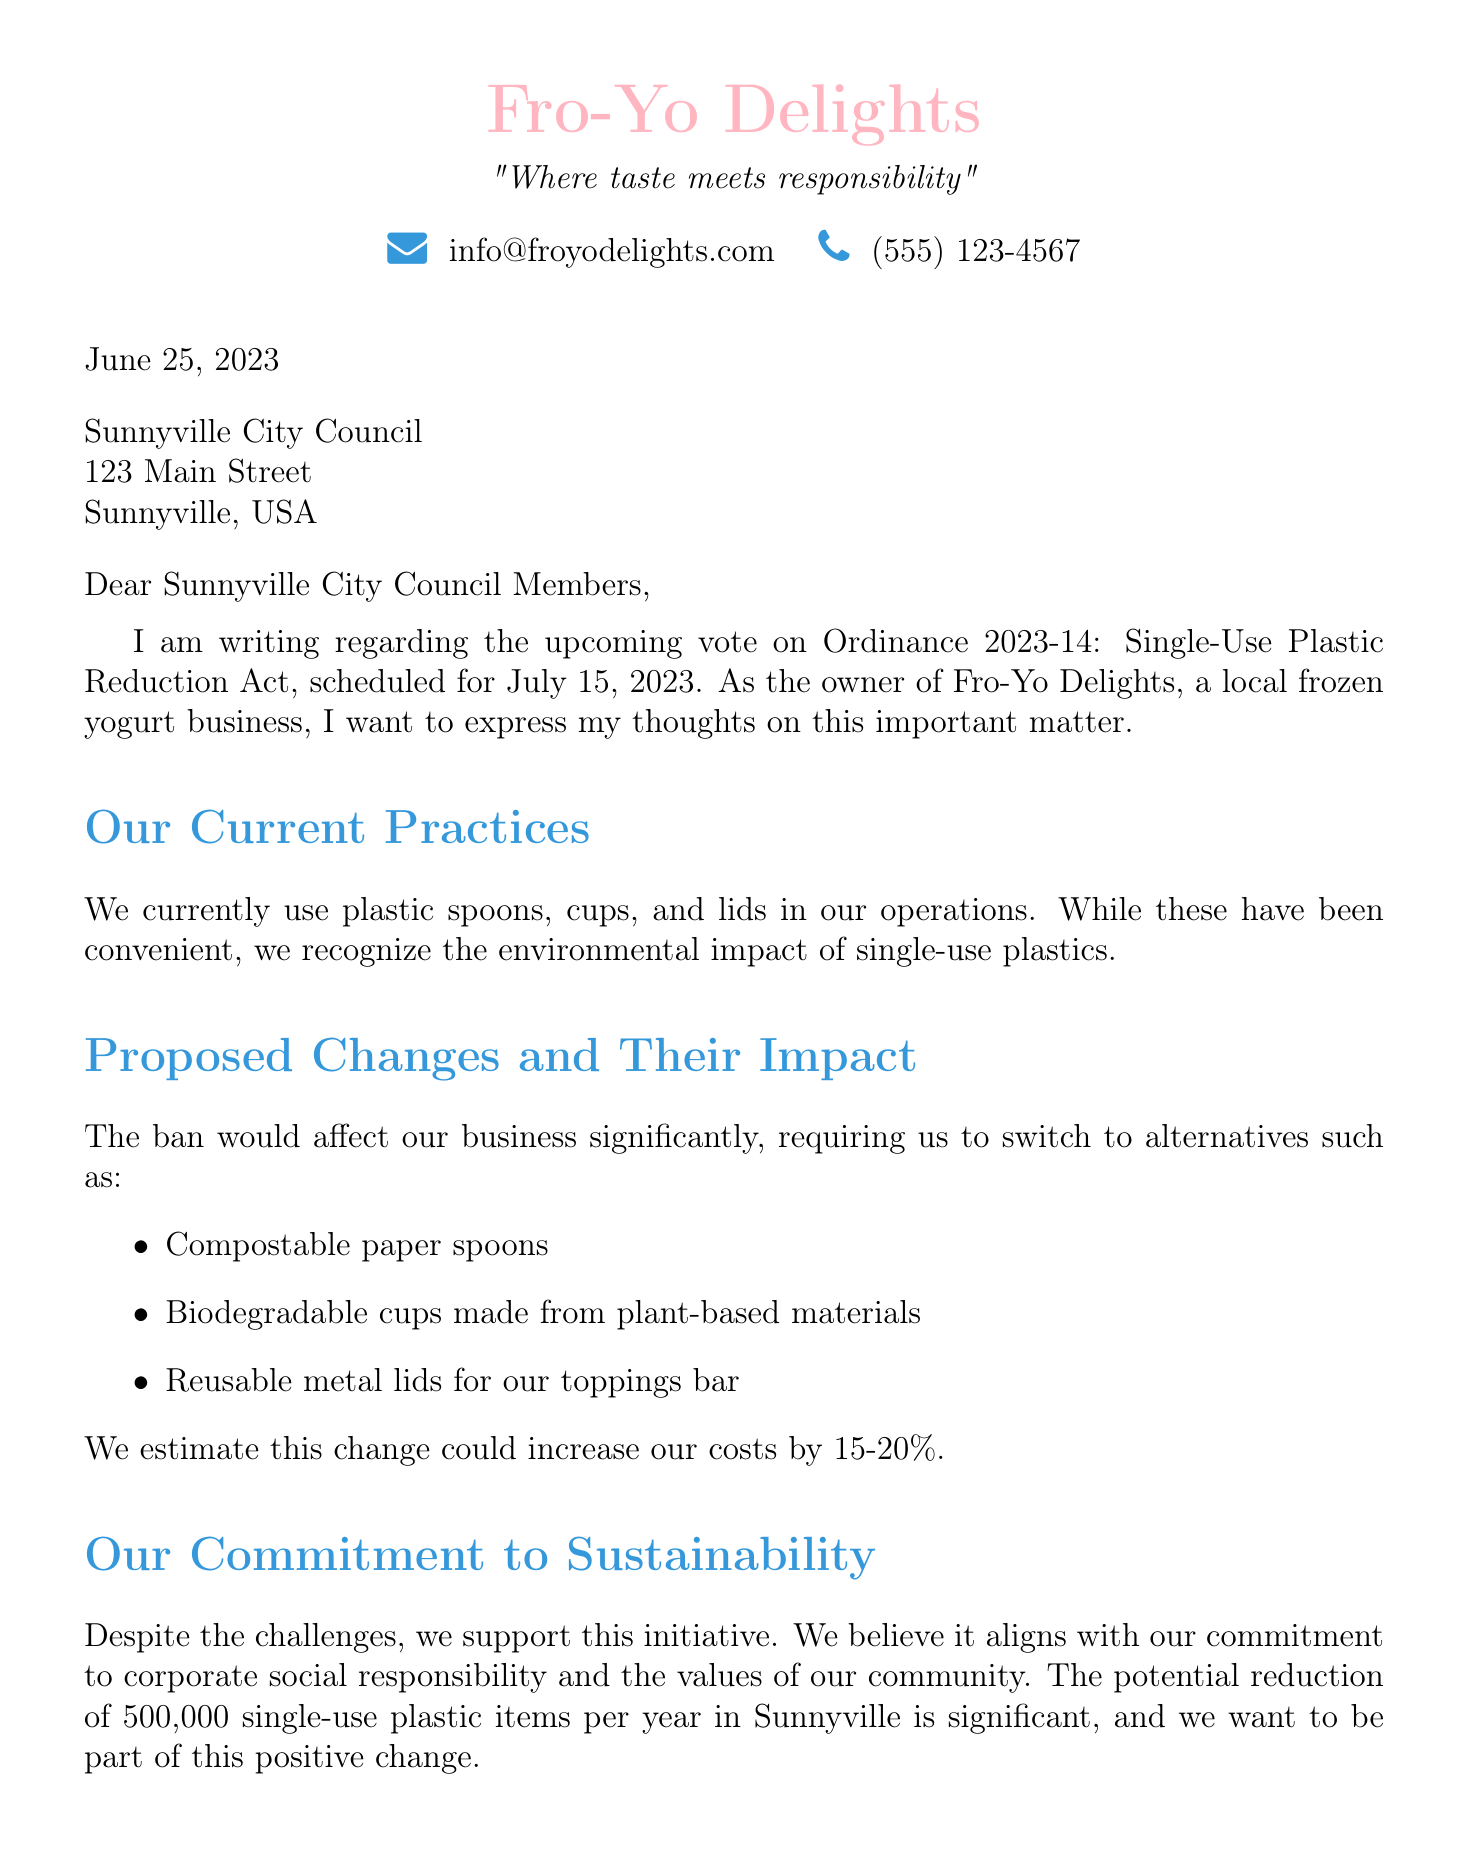What is the name of the ordinance being voted on? The name of the ordinance is mentioned as "Ordinance 2023-14: Single-Use Plastic Reduction Act".
Answer: Ordinance 2023-14: Single-Use Plastic Reduction Act When will the proposed ban take effect? The document states the effective date for the ordinance as January 1, 2024.
Answer: January 1, 2024 What items are affected by the proposed ban? The letter lists several items impacted by the ban, including "plastic straws, plastic utensils, plastic cups, plastic lids, plastic containers for takeout food".
Answer: plastic straws, plastic utensils, plastic cups, plastic lids, plastic containers for takeout food What is the estimated cost increase for eco-friendly alternatives? The letter indicates that the estimated cost increase for transitioning to eco-friendly alternatives is 15-20%.
Answer: 15-20% How many single-use plastic items are estimated to be reduced each year in Sunnyville? The letter notes an estimated reduction of 500,000 single-use plastic items per year in Sunnyville.
Answer: 500,000 What is the support rate among Sunnyville residents for the ban? The document mentions that 65% of Sunnyville residents are in favor of the ban.
Answer: 65% What is the date of the upcoming Business Owners Forum? The document provides the date for the forum as July 5, 2023.
Answer: July 5, 2023 What main request does the business owner make to the City Council? The document lists several requests, but a key one is providing resources or incentives to help small businesses transition.
Answer: Providing resources or incentives to help small businesses transition What opportunity does the document suggest for positioning the business? The letter suggests the opportunity to position the business as an environmental leader.
Answer: To position the business as an environmental leader 